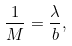Convert formula to latex. <formula><loc_0><loc_0><loc_500><loc_500>\frac { 1 } { M } = \frac { \lambda } { b } ,</formula> 